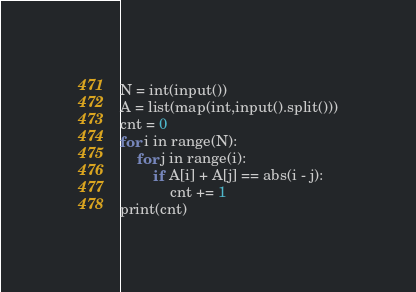Convert code to text. <code><loc_0><loc_0><loc_500><loc_500><_Python_>N = int(input())
A = list(map(int,input().split()))
cnt = 0
for i in range(N):
    for j in range(i):
        if A[i] + A[j] == abs(i - j):
            cnt += 1
print(cnt)</code> 